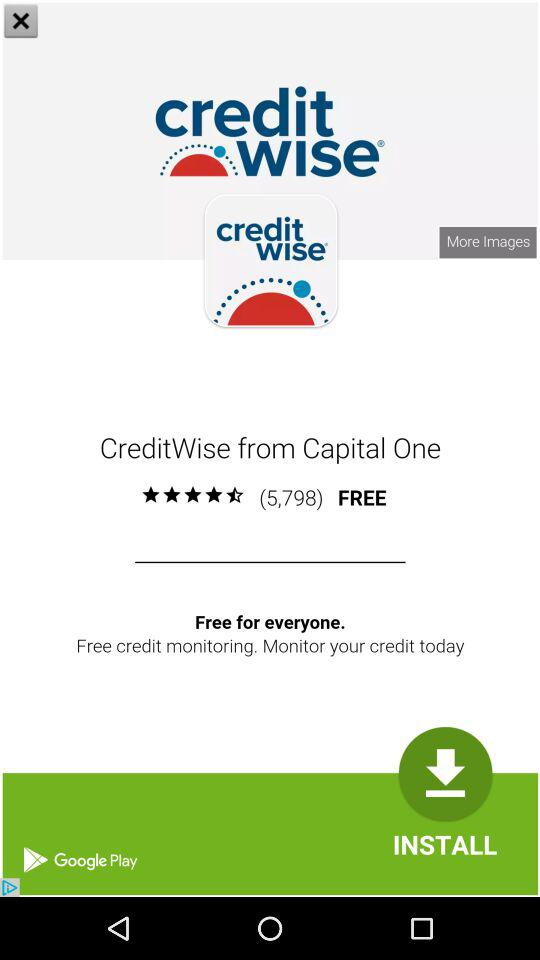How many ratings are there for CreditWise?
Answer the question using a single word or phrase. 5,798 